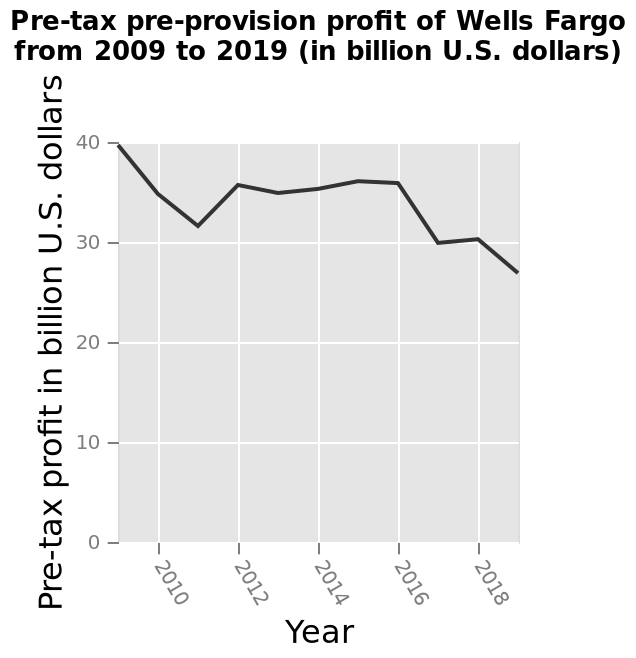<image>
What is the range for the x-axis on the line diagram?  The x-axis on the line diagram measures Year with a linear scale ranging from 2010 to 2018. What does the line diagram represent?  The line diagram represents the pre-tax pre-provision profit of Wells Fargo from 2009 to 2019 in billion U.S. dollars. What is the minimum year value shown on the x-axis of the line diagram?  The minimum year value shown on the x-axis of the line diagram is 2010. Did Wells Fargo experience a decrease in pre-tax pre-provision profits from 2009 to 2019? Yes, Wells Fargo's pre-tax pre-provision profits decreased from 40 billion in 2009 to about 27 billion in 2019. Does the x-axis on the line diagram measure Height with a logarithmic scale ranging from 100 to 1000? No. The x-axis on the line diagram measures Year with a linear scale ranging from 2010 to 2018. 